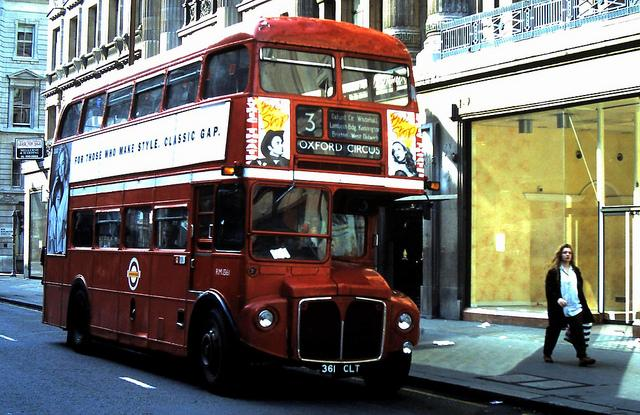What is one of the stops for this bus? Please explain your reasoning. oxford circus. The sign on the front of the bus indicates where it stops. 